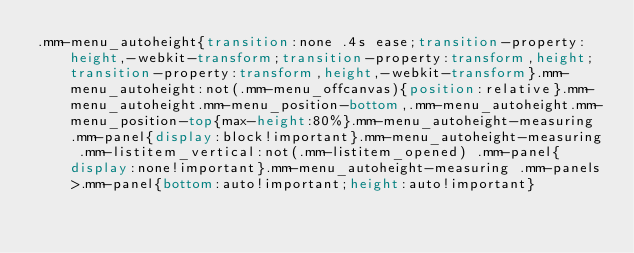<code> <loc_0><loc_0><loc_500><loc_500><_CSS_>.mm-menu_autoheight{transition:none .4s ease;transition-property:height,-webkit-transform;transition-property:transform,height;transition-property:transform,height,-webkit-transform}.mm-menu_autoheight:not(.mm-menu_offcanvas){position:relative}.mm-menu_autoheight.mm-menu_position-bottom,.mm-menu_autoheight.mm-menu_position-top{max-height:80%}.mm-menu_autoheight-measuring .mm-panel{display:block!important}.mm-menu_autoheight-measuring .mm-listitem_vertical:not(.mm-listitem_opened) .mm-panel{display:none!important}.mm-menu_autoheight-measuring .mm-panels>.mm-panel{bottom:auto!important;height:auto!important}</code> 